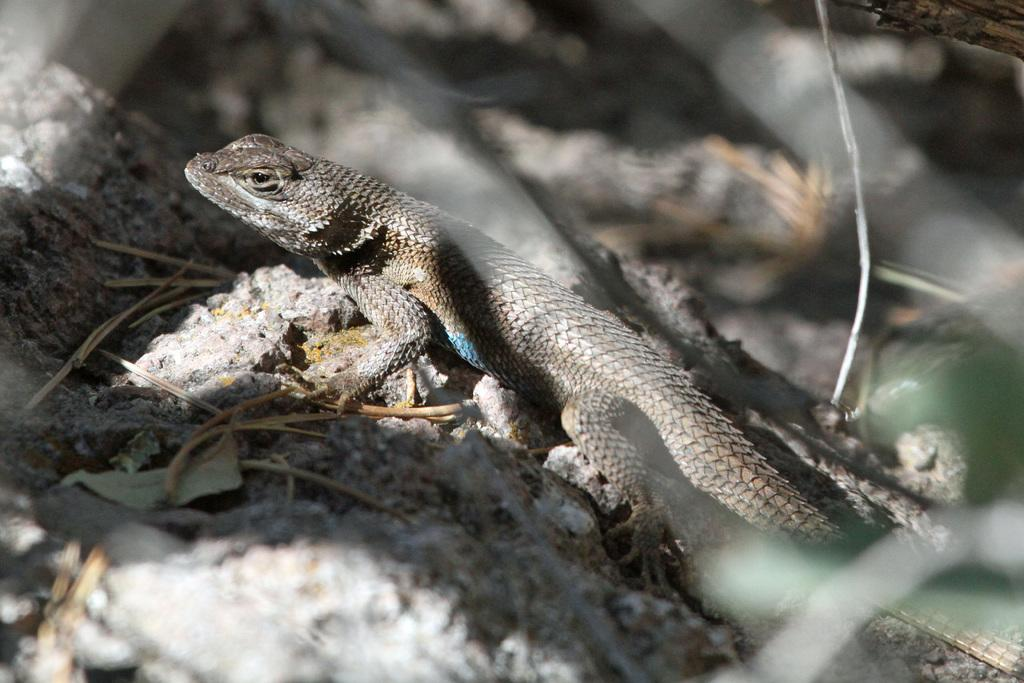What is the main subject of the image? There is a garden lizard in the center of the image. What can be seen in the background of the image? There are stones and twigs in the background of the image. What type of drug is the toad carrying in the image? There is no toad present in the image, and therefore no such activity can be observed. 